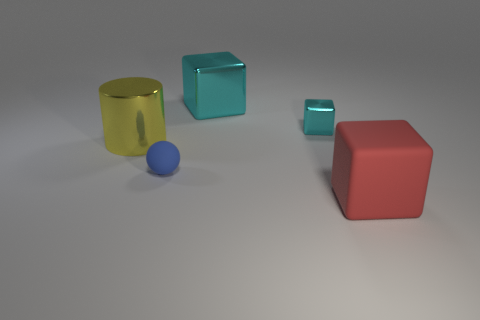There is a big shiny thing that is the same color as the tiny shiny object; what is its shape?
Ensure brevity in your answer.  Cube. The blue rubber object is what size?
Keep it short and to the point. Small. How many cyan metal cubes are the same size as the yellow cylinder?
Give a very brief answer. 1. What is the material of the tiny object that is the same shape as the large red rubber thing?
Your answer should be compact. Metal. There is a thing that is both in front of the yellow shiny cylinder and to the left of the red thing; what is its shape?
Ensure brevity in your answer.  Sphere. The metal object that is left of the tiny blue sphere has what shape?
Your answer should be compact. Cylinder. How many large objects are to the right of the yellow cylinder and on the left side of the tiny cyan thing?
Provide a succinct answer. 1. There is a yellow metal object; is its size the same as the rubber thing in front of the tiny blue thing?
Offer a terse response. Yes. What size is the rubber object that is left of the red rubber cube that is to the right of the cyan metal object in front of the big metal cube?
Provide a short and direct response. Small. There is a matte object in front of the tiny ball; what is its size?
Give a very brief answer. Large. 